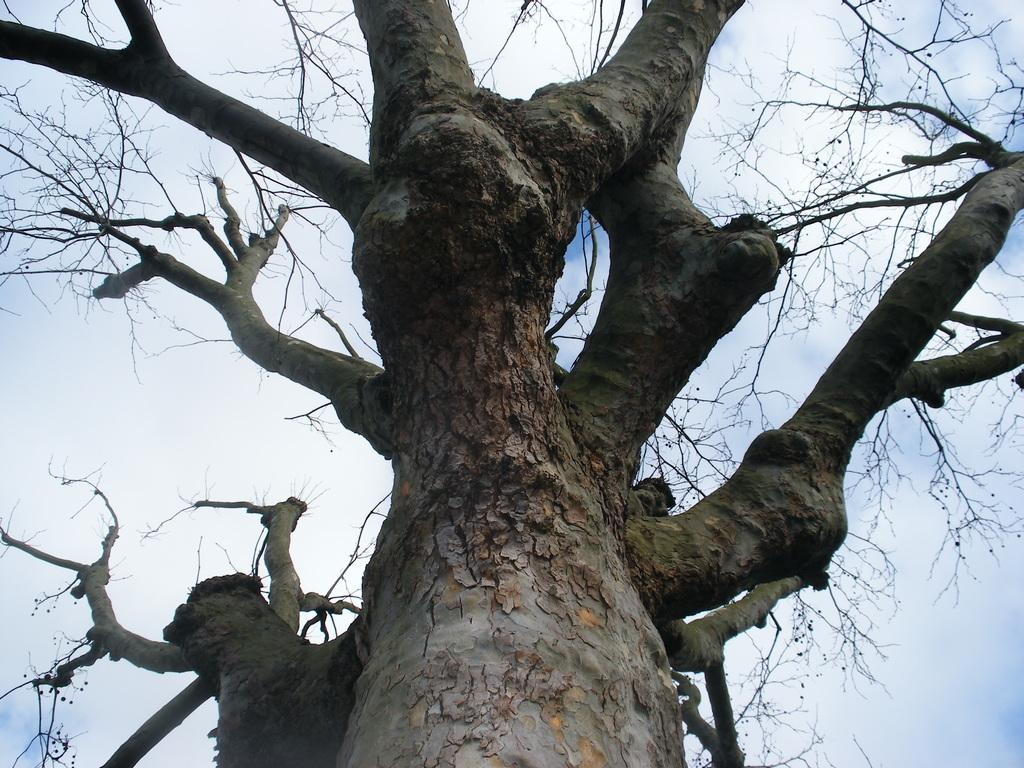What type of tree is in the image? There is a dried tree in the image. What is the condition of the sky in the image? The sky is cloudy in the image. Can you hear any cow sounds in the image? There are no cow sounds present in the image, as it is a visual representation and does not include audio. What type of songs are being sung in the scene depicted in the image? There is no scene or singing present in the image; it only features a dried tree and a cloudy sky. 